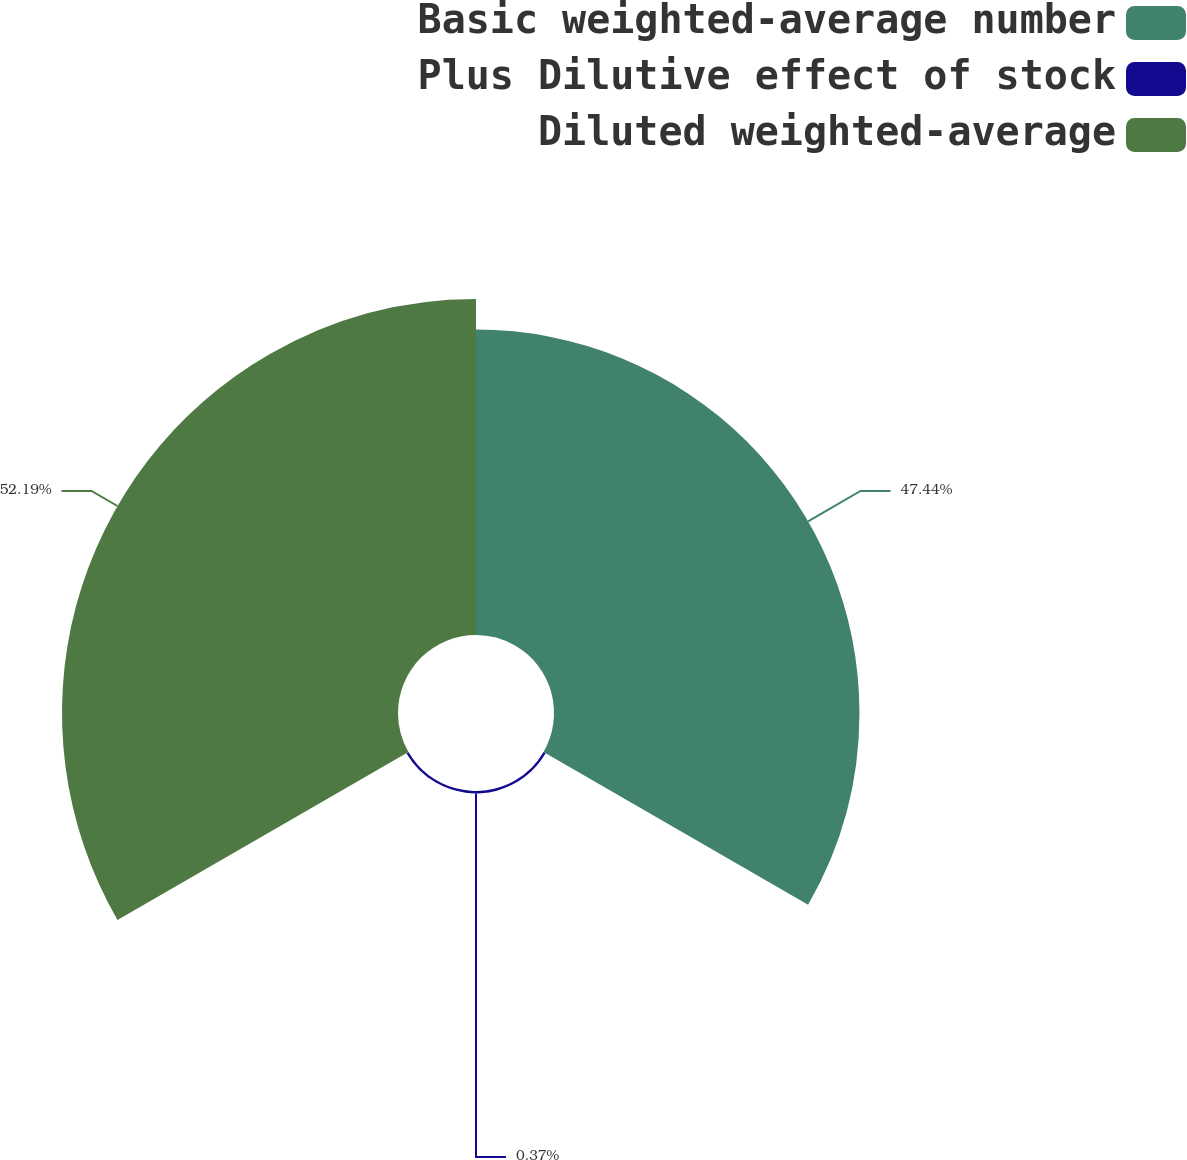Convert chart. <chart><loc_0><loc_0><loc_500><loc_500><pie_chart><fcel>Basic weighted-average number<fcel>Plus Dilutive effect of stock<fcel>Diluted weighted-average<nl><fcel>47.44%<fcel>0.37%<fcel>52.18%<nl></chart> 